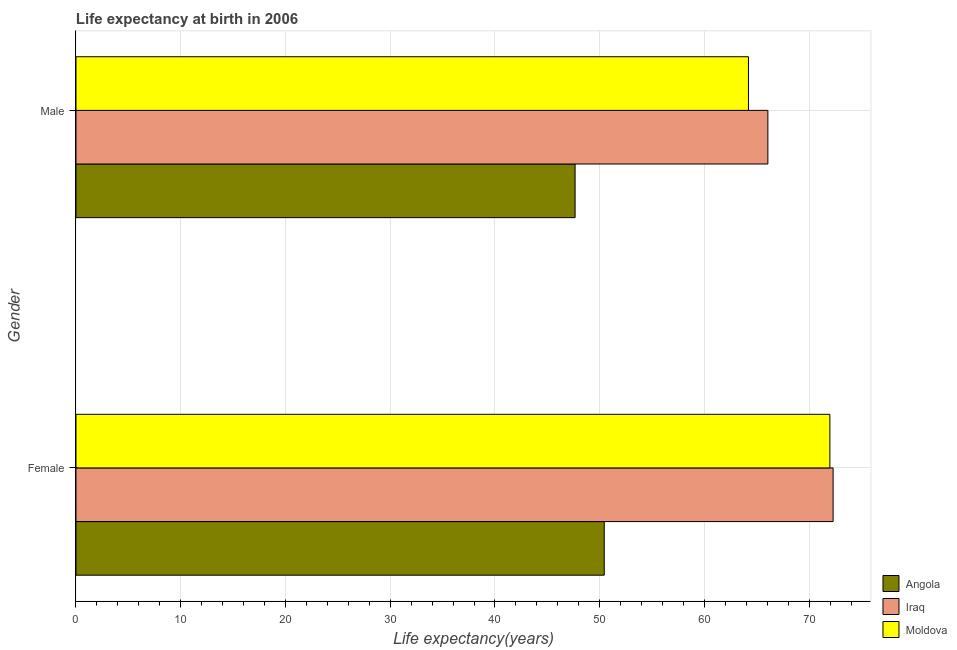Are the number of bars per tick equal to the number of legend labels?
Your answer should be compact. Yes. Are the number of bars on each tick of the Y-axis equal?
Offer a terse response. Yes. How many bars are there on the 2nd tick from the top?
Offer a terse response. 3. What is the life expectancy(female) in Moldova?
Give a very brief answer. 71.97. Across all countries, what is the maximum life expectancy(male)?
Keep it short and to the point. 66.05. Across all countries, what is the minimum life expectancy(male)?
Provide a short and direct response. 47.65. In which country was the life expectancy(female) maximum?
Offer a terse response. Iraq. In which country was the life expectancy(female) minimum?
Give a very brief answer. Angola. What is the total life expectancy(male) in the graph?
Ensure brevity in your answer.  177.9. What is the difference between the life expectancy(female) in Moldova and that in Iraq?
Offer a very short reply. -0.31. What is the difference between the life expectancy(female) in Angola and the life expectancy(male) in Moldova?
Your answer should be compact. -13.77. What is the average life expectancy(female) per country?
Provide a short and direct response. 64.9. What is the difference between the life expectancy(male) and life expectancy(female) in Angola?
Ensure brevity in your answer.  -2.78. What is the ratio of the life expectancy(male) in Iraq to that in Moldova?
Make the answer very short. 1.03. Is the life expectancy(male) in Iraq less than that in Moldova?
Offer a very short reply. No. What does the 2nd bar from the top in Female represents?
Your response must be concise. Iraq. What does the 1st bar from the bottom in Male represents?
Ensure brevity in your answer.  Angola. Are all the bars in the graph horizontal?
Your response must be concise. Yes. How many countries are there in the graph?
Ensure brevity in your answer.  3. Where does the legend appear in the graph?
Offer a terse response. Bottom right. How many legend labels are there?
Offer a very short reply. 3. What is the title of the graph?
Your answer should be very brief. Life expectancy at birth in 2006. What is the label or title of the X-axis?
Offer a very short reply. Life expectancy(years). What is the Life expectancy(years) in Angola in Female?
Your answer should be very brief. 50.43. What is the Life expectancy(years) of Iraq in Female?
Give a very brief answer. 72.28. What is the Life expectancy(years) in Moldova in Female?
Provide a succinct answer. 71.97. What is the Life expectancy(years) in Angola in Male?
Your answer should be very brief. 47.65. What is the Life expectancy(years) in Iraq in Male?
Provide a succinct answer. 66.05. What is the Life expectancy(years) of Moldova in Male?
Your answer should be compact. 64.2. Across all Gender, what is the maximum Life expectancy(years) of Angola?
Offer a very short reply. 50.43. Across all Gender, what is the maximum Life expectancy(years) in Iraq?
Provide a succinct answer. 72.28. Across all Gender, what is the maximum Life expectancy(years) in Moldova?
Give a very brief answer. 71.97. Across all Gender, what is the minimum Life expectancy(years) in Angola?
Your answer should be very brief. 47.65. Across all Gender, what is the minimum Life expectancy(years) in Iraq?
Your answer should be compact. 66.05. Across all Gender, what is the minimum Life expectancy(years) of Moldova?
Your answer should be compact. 64.2. What is the total Life expectancy(years) of Angola in the graph?
Provide a short and direct response. 98.08. What is the total Life expectancy(years) of Iraq in the graph?
Your answer should be compact. 138.34. What is the total Life expectancy(years) of Moldova in the graph?
Make the answer very short. 136.17. What is the difference between the Life expectancy(years) in Angola in Female and that in Male?
Offer a very short reply. 2.78. What is the difference between the Life expectancy(years) of Iraq in Female and that in Male?
Your answer should be compact. 6.23. What is the difference between the Life expectancy(years) of Moldova in Female and that in Male?
Offer a very short reply. 7.77. What is the difference between the Life expectancy(years) of Angola in Female and the Life expectancy(years) of Iraq in Male?
Provide a succinct answer. -15.62. What is the difference between the Life expectancy(years) in Angola in Female and the Life expectancy(years) in Moldova in Male?
Keep it short and to the point. -13.77. What is the difference between the Life expectancy(years) of Iraq in Female and the Life expectancy(years) of Moldova in Male?
Offer a very short reply. 8.08. What is the average Life expectancy(years) in Angola per Gender?
Give a very brief answer. 49.04. What is the average Life expectancy(years) of Iraq per Gender?
Ensure brevity in your answer.  69.17. What is the average Life expectancy(years) in Moldova per Gender?
Provide a short and direct response. 68.09. What is the difference between the Life expectancy(years) in Angola and Life expectancy(years) in Iraq in Female?
Your answer should be very brief. -21.85. What is the difference between the Life expectancy(years) of Angola and Life expectancy(years) of Moldova in Female?
Your response must be concise. -21.54. What is the difference between the Life expectancy(years) of Iraq and Life expectancy(years) of Moldova in Female?
Offer a very short reply. 0.31. What is the difference between the Life expectancy(years) of Angola and Life expectancy(years) of Iraq in Male?
Offer a very short reply. -18.41. What is the difference between the Life expectancy(years) in Angola and Life expectancy(years) in Moldova in Male?
Give a very brief answer. -16.55. What is the difference between the Life expectancy(years) in Iraq and Life expectancy(years) in Moldova in Male?
Make the answer very short. 1.85. What is the ratio of the Life expectancy(years) of Angola in Female to that in Male?
Your answer should be compact. 1.06. What is the ratio of the Life expectancy(years) in Iraq in Female to that in Male?
Provide a succinct answer. 1.09. What is the ratio of the Life expectancy(years) in Moldova in Female to that in Male?
Give a very brief answer. 1.12. What is the difference between the highest and the second highest Life expectancy(years) in Angola?
Give a very brief answer. 2.78. What is the difference between the highest and the second highest Life expectancy(years) of Iraq?
Offer a terse response. 6.23. What is the difference between the highest and the second highest Life expectancy(years) in Moldova?
Your response must be concise. 7.77. What is the difference between the highest and the lowest Life expectancy(years) of Angola?
Keep it short and to the point. 2.78. What is the difference between the highest and the lowest Life expectancy(years) in Iraq?
Your answer should be compact. 6.23. What is the difference between the highest and the lowest Life expectancy(years) in Moldova?
Provide a succinct answer. 7.77. 